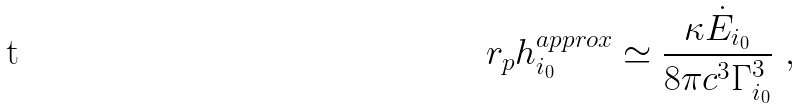<formula> <loc_0><loc_0><loc_500><loc_500>r _ { p } h _ { i _ { 0 } } ^ { a p p r o x } \simeq \frac { \kappa \dot { E } _ { i _ { 0 } } } { 8 \pi c ^ { 3 } \Gamma ^ { 3 } _ { i _ { 0 } } } \ ,</formula> 